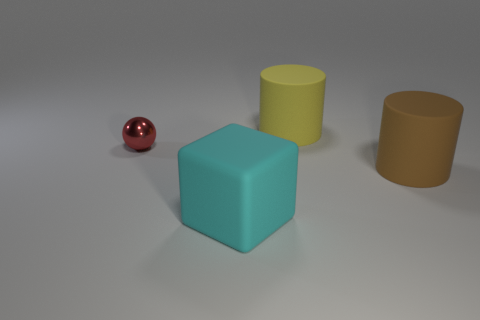Add 2 big blue metal objects. How many objects exist? 6 Subtract all blocks. How many objects are left? 3 Subtract all tiny brown metal spheres. Subtract all large rubber things. How many objects are left? 1 Add 1 large cyan rubber things. How many large cyan rubber things are left? 2 Add 1 big blue metal blocks. How many big blue metal blocks exist? 1 Subtract 1 yellow cylinders. How many objects are left? 3 